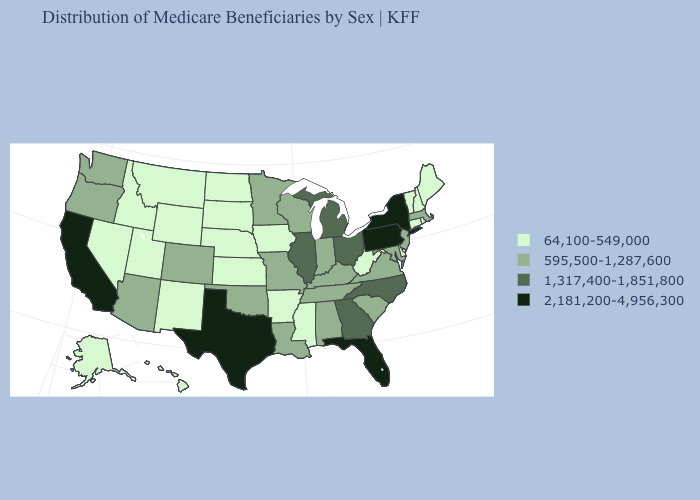What is the value of Oklahoma?
Answer briefly. 595,500-1,287,600. What is the value of Arizona?
Be succinct. 595,500-1,287,600. Name the states that have a value in the range 595,500-1,287,600?
Write a very short answer. Alabama, Arizona, Colorado, Indiana, Kentucky, Louisiana, Maryland, Massachusetts, Minnesota, Missouri, New Jersey, Oklahoma, Oregon, South Carolina, Tennessee, Virginia, Washington, Wisconsin. Name the states that have a value in the range 595,500-1,287,600?
Write a very short answer. Alabama, Arizona, Colorado, Indiana, Kentucky, Louisiana, Maryland, Massachusetts, Minnesota, Missouri, New Jersey, Oklahoma, Oregon, South Carolina, Tennessee, Virginia, Washington, Wisconsin. Does the first symbol in the legend represent the smallest category?
Write a very short answer. Yes. Name the states that have a value in the range 595,500-1,287,600?
Answer briefly. Alabama, Arizona, Colorado, Indiana, Kentucky, Louisiana, Maryland, Massachusetts, Minnesota, Missouri, New Jersey, Oklahoma, Oregon, South Carolina, Tennessee, Virginia, Washington, Wisconsin. Among the states that border Nevada , does California have the highest value?
Be succinct. Yes. Which states have the highest value in the USA?
Give a very brief answer. California, Florida, New York, Pennsylvania, Texas. What is the value of Colorado?
Give a very brief answer. 595,500-1,287,600. Name the states that have a value in the range 2,181,200-4,956,300?
Short answer required. California, Florida, New York, Pennsylvania, Texas. Does Washington have a higher value than Tennessee?
Be succinct. No. Does Massachusetts have the same value as Missouri?
Keep it brief. Yes. What is the lowest value in states that border New Jersey?
Concise answer only. 64,100-549,000. What is the value of Ohio?
Be succinct. 1,317,400-1,851,800. Name the states that have a value in the range 1,317,400-1,851,800?
Quick response, please. Georgia, Illinois, Michigan, North Carolina, Ohio. 